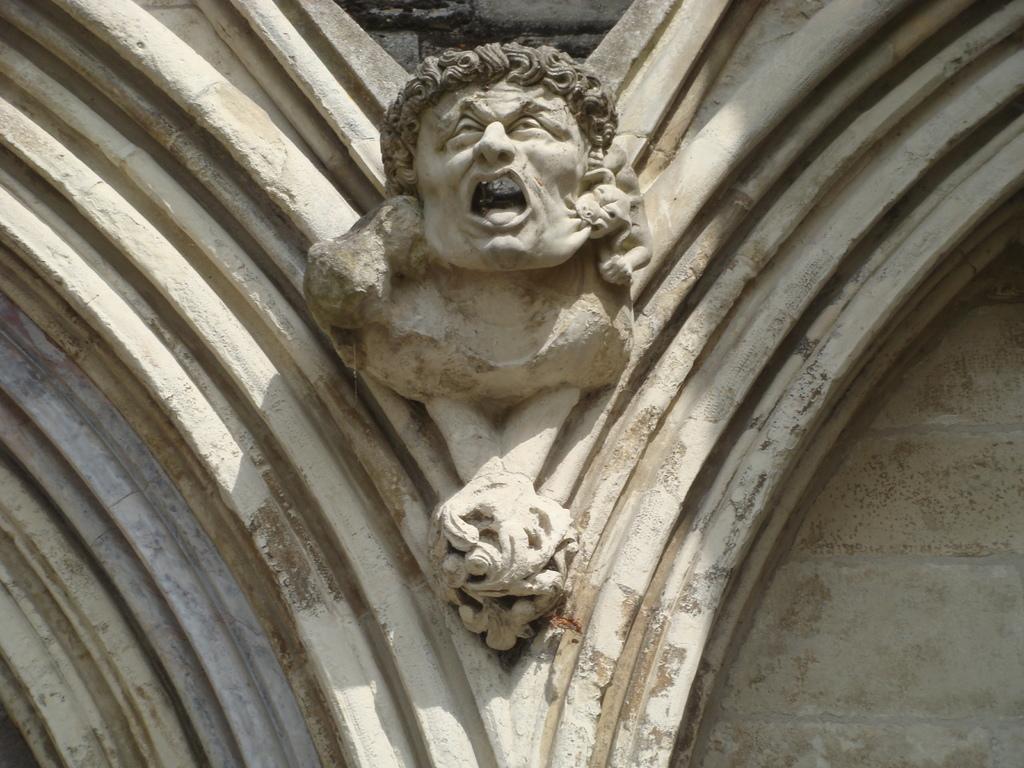Describe this image in one or two sentences. In this image we can see the sculpture on the wall. 